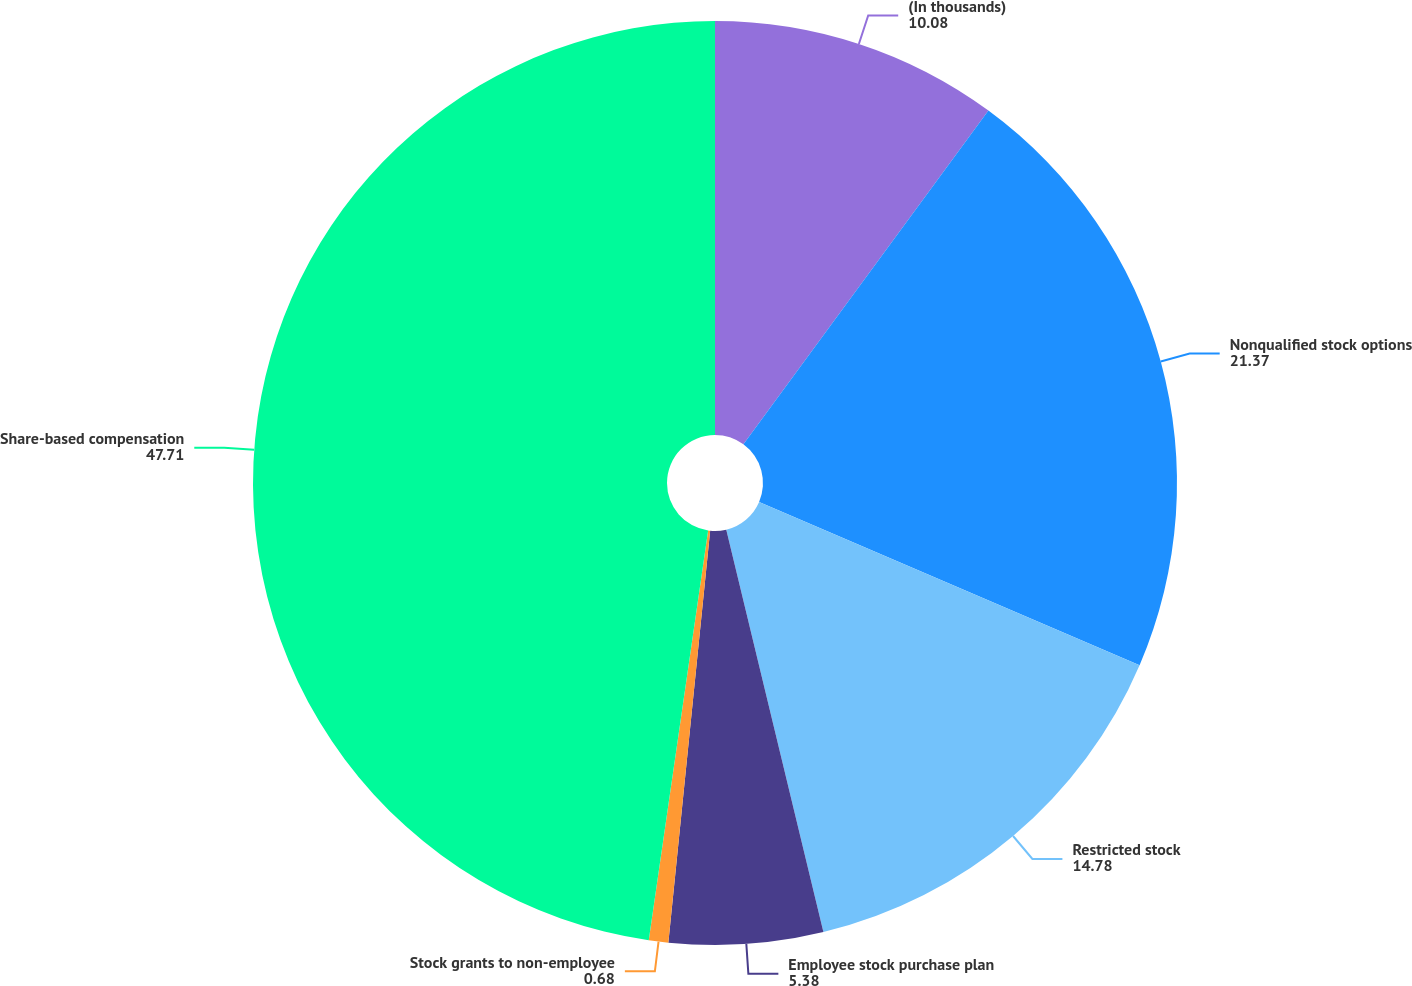<chart> <loc_0><loc_0><loc_500><loc_500><pie_chart><fcel>(In thousands)<fcel>Nonqualified stock options<fcel>Restricted stock<fcel>Employee stock purchase plan<fcel>Stock grants to non-employee<fcel>Share-based compensation<nl><fcel>10.08%<fcel>21.37%<fcel>14.78%<fcel>5.38%<fcel>0.68%<fcel>47.71%<nl></chart> 